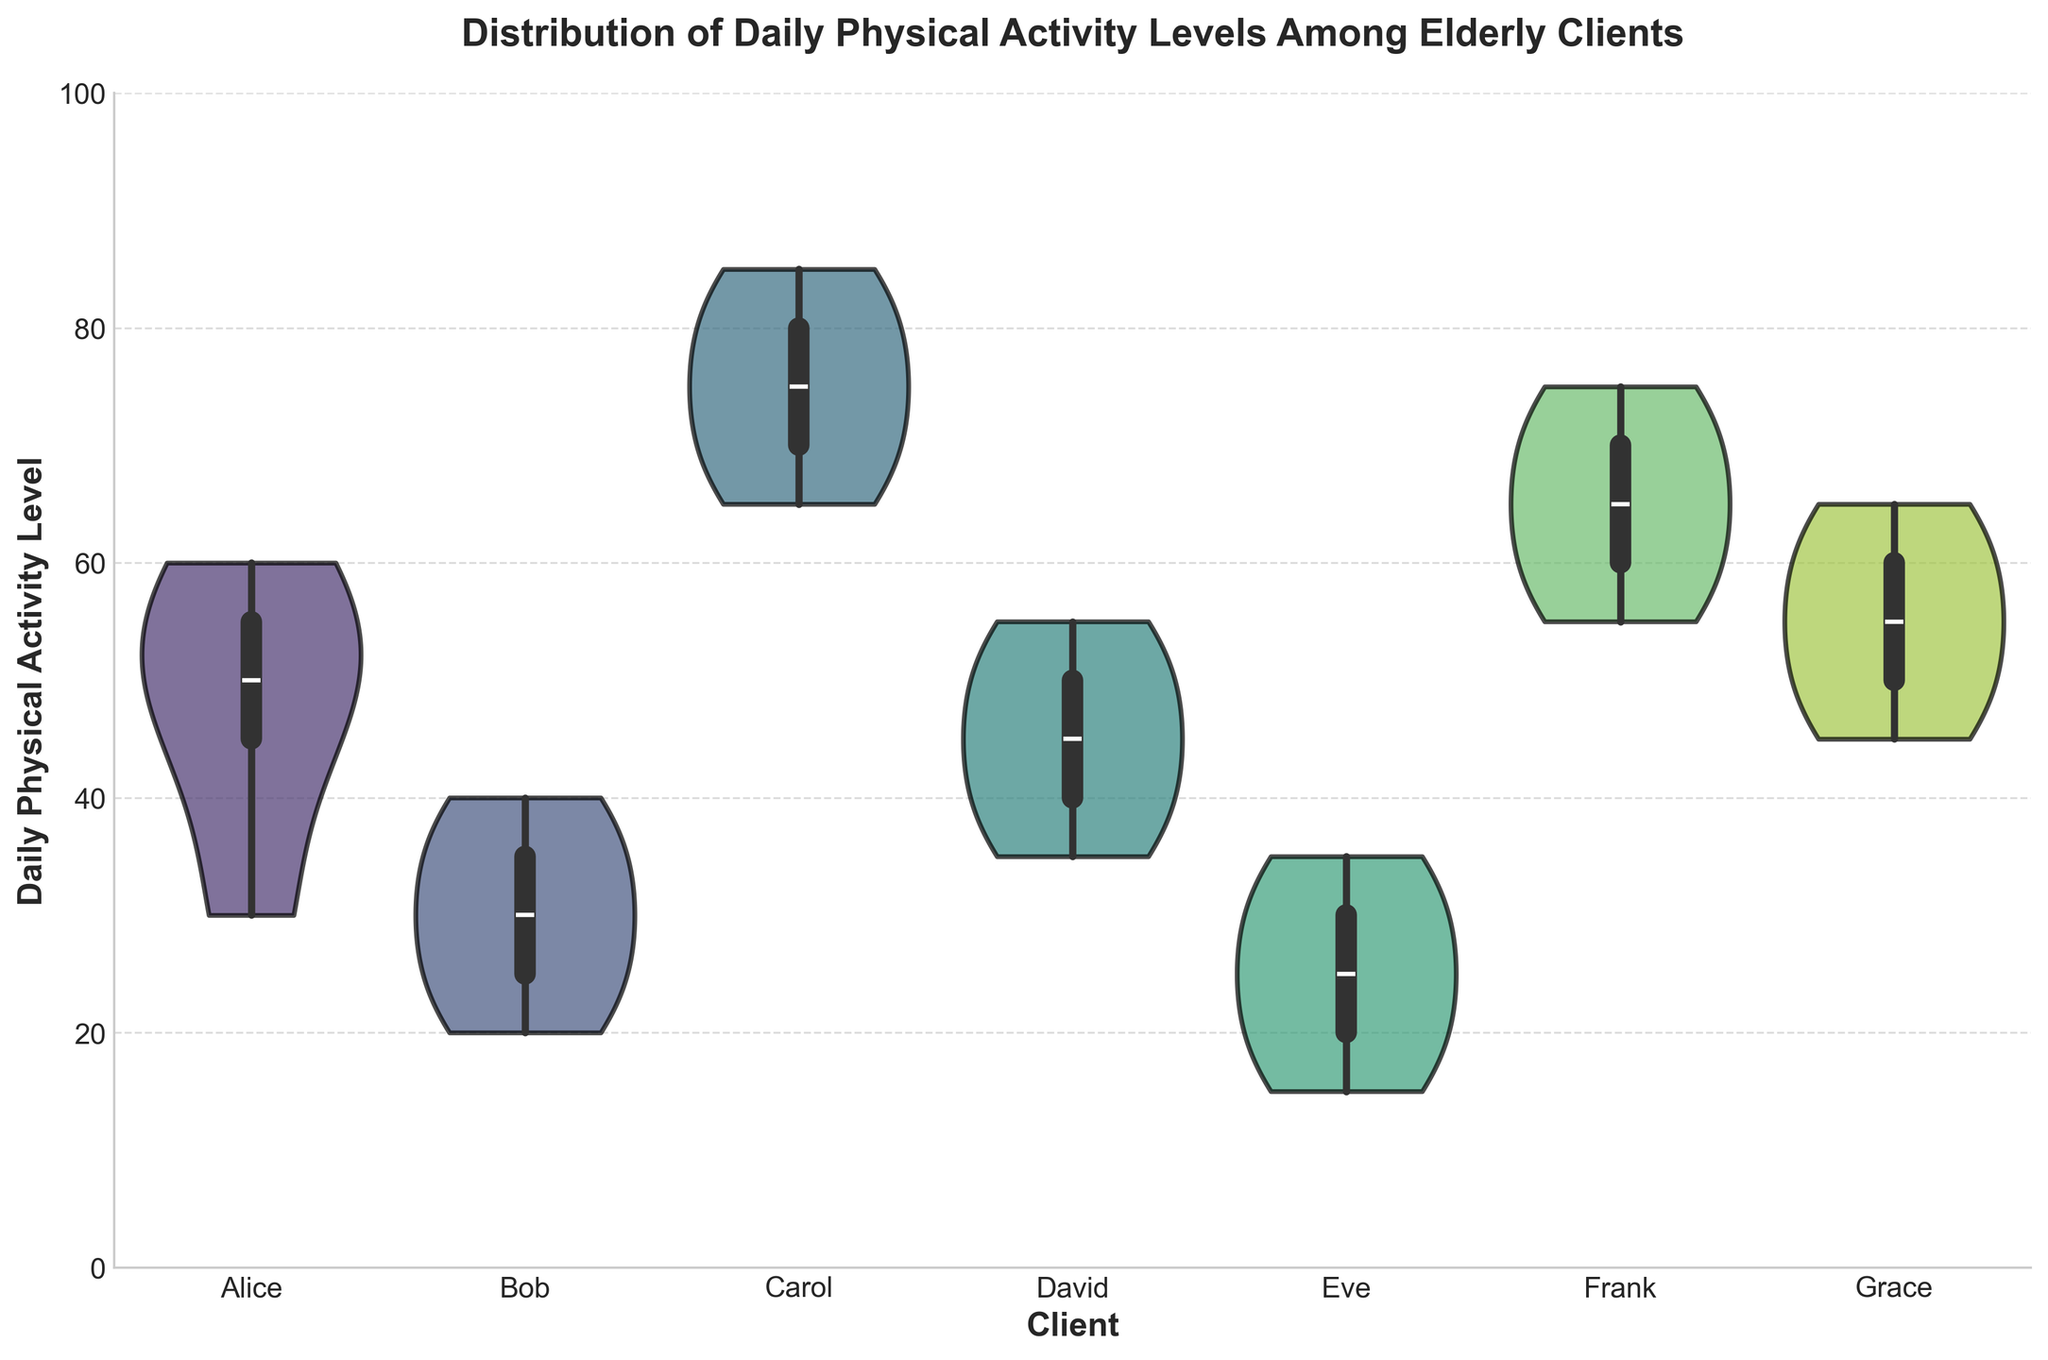What is the title of the figure? The title of the figure is usually found at the top of the plot. It provides a short description of what the plot represents. Here, it states the theme of the data visualization.
Answer: Distribution of Daily Physical Activity Levels Among Elderly Clients What is the scale of the y-axis? The y-axis represents the Daily Physical Activity Level. The scale of an axis is usually marked by numbers indicating the range of the data. Here, it ranges from a minimum to a maximum value.
Answer: 0 to 100 Which client shows the highest range in daily physical activity levels? To determine the highest range, observe the spread of the data points for each client. The client with the widest spread from top to bottom has the highest range.
Answer: Carol Which client has the lowest median physical activity level? Median values are indicated by the middle bar inside the violin plot. The client whose plot has the lowest median bar represents the lowest median physical activity level.
Answer: Eve Compare the physical activity levels of Alice and Bob. Who has higher median activity? The median is typically shown by a horizontal line within the violin plot. Compare the position of the median lines for Alice and Bob.
Answer: Alice Which clients have physical activity levels that overlap? Overlapping levels are where the violin plot bands for different clients intersect. Look for clients whose violin plot shapes have overlaps in the y-axis range.
Answer: Multiple pairs such as Alice and David Is there a client whose data shows bimodal distribution? A bimodal distribution will show two distinct peaks within the same client’s violin plot. Look for a violin plot with two high-density areas.
Answer: Grace (potentially) What can you infer about Frank's daily physical activity levels? To infer information, observe the spread of the data within Frank's violin plot, including range, distribution shape, and median.
Answer: Frank's activity levels are well-spread with higher median values Which client shows the most concentrated levels of physical activity? Concentration is indicated by a narrower and taller violin plot, showing that data points are closer together.
Answer: Bob 